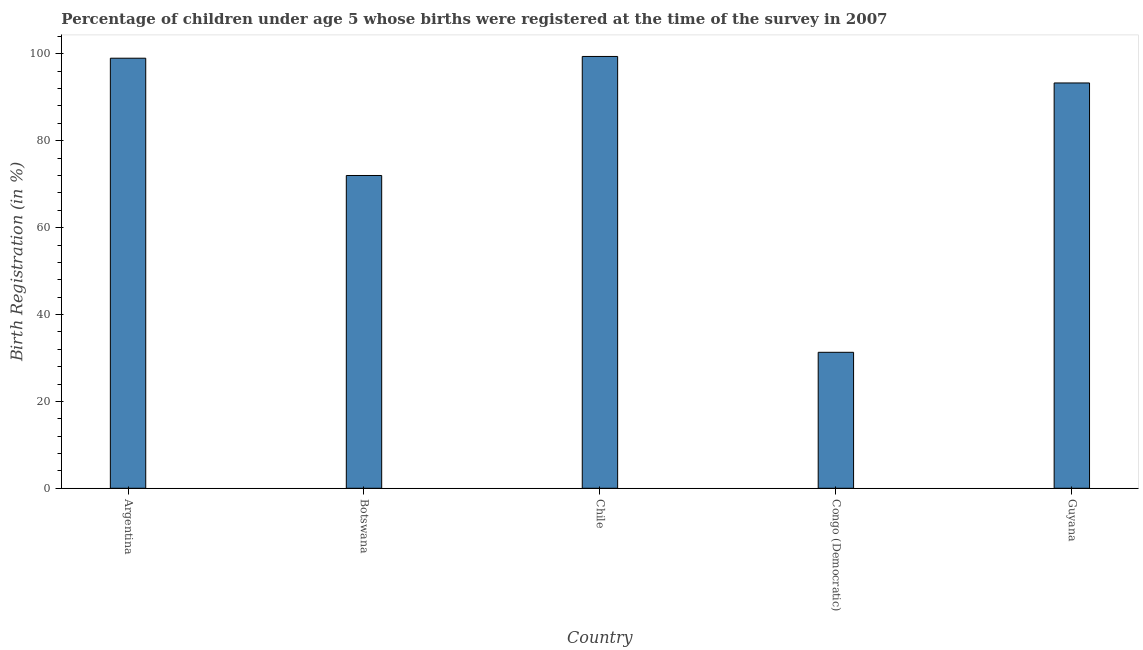Does the graph contain any zero values?
Provide a succinct answer. No. Does the graph contain grids?
Provide a succinct answer. No. What is the title of the graph?
Ensure brevity in your answer.  Percentage of children under age 5 whose births were registered at the time of the survey in 2007. What is the label or title of the Y-axis?
Provide a succinct answer. Birth Registration (in %). What is the birth registration in Botswana?
Keep it short and to the point. 72. Across all countries, what is the maximum birth registration?
Provide a succinct answer. 99.4. Across all countries, what is the minimum birth registration?
Ensure brevity in your answer.  31.3. In which country was the birth registration minimum?
Provide a short and direct response. Congo (Democratic). What is the sum of the birth registration?
Offer a terse response. 395. What is the difference between the birth registration in Botswana and Congo (Democratic)?
Give a very brief answer. 40.7. What is the average birth registration per country?
Provide a succinct answer. 79. What is the median birth registration?
Ensure brevity in your answer.  93.3. In how many countries, is the birth registration greater than 56 %?
Keep it short and to the point. 4. What is the ratio of the birth registration in Botswana to that in Guyana?
Provide a succinct answer. 0.77. Is the birth registration in Argentina less than that in Chile?
Offer a very short reply. Yes. Is the difference between the birth registration in Botswana and Chile greater than the difference between any two countries?
Give a very brief answer. No. Is the sum of the birth registration in Argentina and Guyana greater than the maximum birth registration across all countries?
Your response must be concise. Yes. What is the difference between the highest and the lowest birth registration?
Offer a terse response. 68.1. In how many countries, is the birth registration greater than the average birth registration taken over all countries?
Give a very brief answer. 3. How many bars are there?
Your answer should be very brief. 5. How many countries are there in the graph?
Offer a terse response. 5. Are the values on the major ticks of Y-axis written in scientific E-notation?
Give a very brief answer. No. What is the Birth Registration (in %) of Argentina?
Provide a succinct answer. 99. What is the Birth Registration (in %) of Chile?
Your response must be concise. 99.4. What is the Birth Registration (in %) in Congo (Democratic)?
Ensure brevity in your answer.  31.3. What is the Birth Registration (in %) of Guyana?
Offer a very short reply. 93.3. What is the difference between the Birth Registration (in %) in Argentina and Botswana?
Your response must be concise. 27. What is the difference between the Birth Registration (in %) in Argentina and Congo (Democratic)?
Your response must be concise. 67.7. What is the difference between the Birth Registration (in %) in Argentina and Guyana?
Provide a succinct answer. 5.7. What is the difference between the Birth Registration (in %) in Botswana and Chile?
Keep it short and to the point. -27.4. What is the difference between the Birth Registration (in %) in Botswana and Congo (Democratic)?
Your answer should be compact. 40.7. What is the difference between the Birth Registration (in %) in Botswana and Guyana?
Make the answer very short. -21.3. What is the difference between the Birth Registration (in %) in Chile and Congo (Democratic)?
Your answer should be compact. 68.1. What is the difference between the Birth Registration (in %) in Chile and Guyana?
Your answer should be compact. 6.1. What is the difference between the Birth Registration (in %) in Congo (Democratic) and Guyana?
Offer a terse response. -62. What is the ratio of the Birth Registration (in %) in Argentina to that in Botswana?
Provide a short and direct response. 1.38. What is the ratio of the Birth Registration (in %) in Argentina to that in Chile?
Offer a very short reply. 1. What is the ratio of the Birth Registration (in %) in Argentina to that in Congo (Democratic)?
Keep it short and to the point. 3.16. What is the ratio of the Birth Registration (in %) in Argentina to that in Guyana?
Your answer should be compact. 1.06. What is the ratio of the Birth Registration (in %) in Botswana to that in Chile?
Keep it short and to the point. 0.72. What is the ratio of the Birth Registration (in %) in Botswana to that in Congo (Democratic)?
Provide a short and direct response. 2.3. What is the ratio of the Birth Registration (in %) in Botswana to that in Guyana?
Ensure brevity in your answer.  0.77. What is the ratio of the Birth Registration (in %) in Chile to that in Congo (Democratic)?
Keep it short and to the point. 3.18. What is the ratio of the Birth Registration (in %) in Chile to that in Guyana?
Provide a succinct answer. 1.06. What is the ratio of the Birth Registration (in %) in Congo (Democratic) to that in Guyana?
Offer a terse response. 0.34. 